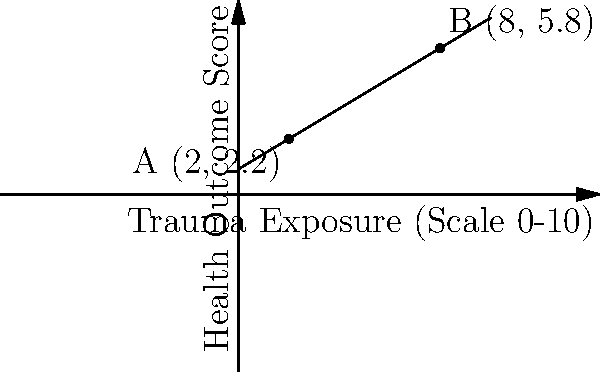In a study on the correlation between trauma exposure and health outcomes in a specific marginalized community, researchers plotted data points on a graph. Two significant points, A(2, 2.2) and B(8, 5.8), were identified. Calculate the slope of the line connecting these two points, which represents the rate of change in health outcomes relative to trauma exposure. To calculate the slope of the line connecting points A(2, 2.2) and B(8, 5.8), we'll use the slope formula:

$$ \text{slope} = m = \frac{y_2 - y_1}{x_2 - x_1} $$

Where $(x_1, y_1)$ is point A and $(x_2, y_2)$ is point B.

Step 1: Identify the coordinates
- Point A: $(x_1, y_1) = (2, 2.2)$
- Point B: $(x_2, y_2) = (8, 5.8)$

Step 2: Substitute the values into the slope formula
$$ m = \frac{5.8 - 2.2}{8 - 2} $$

Step 3: Calculate the numerator and denominator
$$ m = \frac{3.6}{6} $$

Step 4: Divide to get the final slope
$$ m = 0.6 $$

The slope of 0.6 indicates that for every 1-unit increase in trauma exposure, there is a 0.6-unit increase in the health outcome score.
Answer: 0.6 